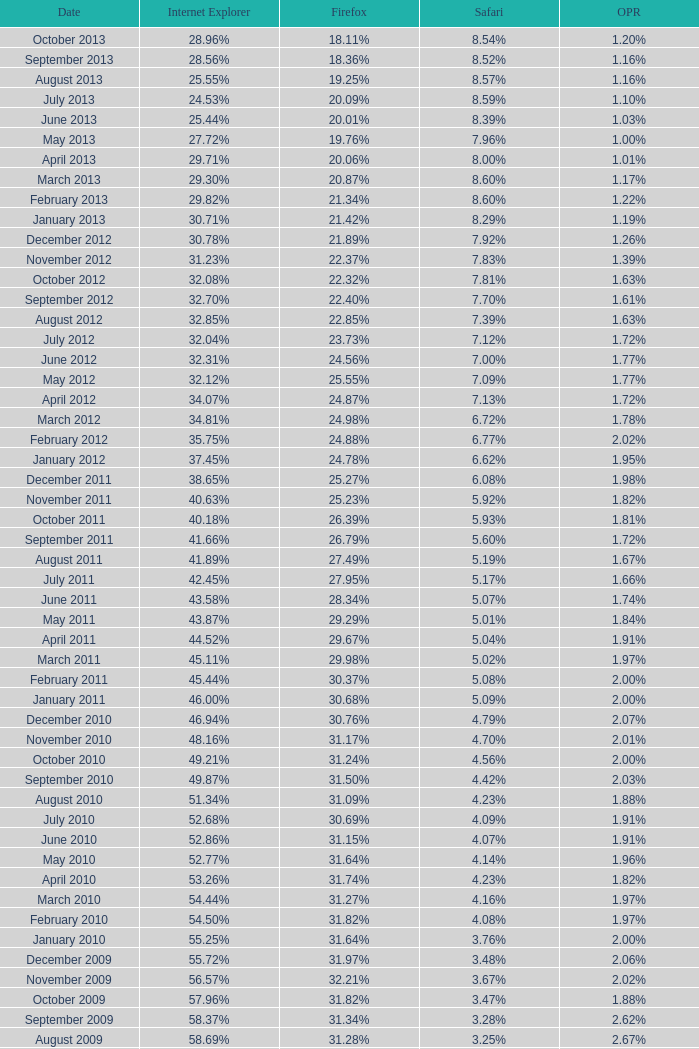What percentage of browsers were using Opera in November 2009? 2.02%. 